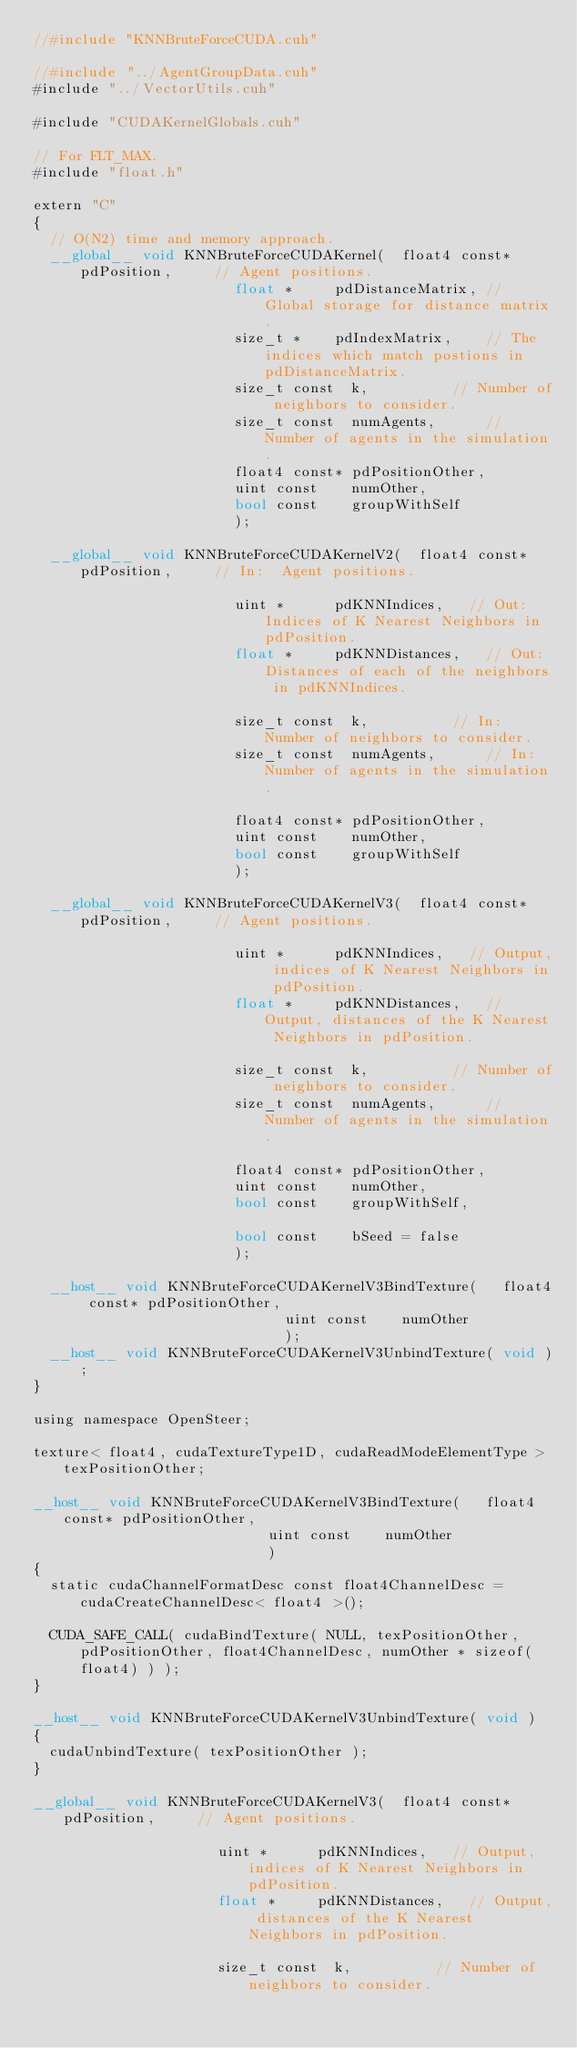<code> <loc_0><loc_0><loc_500><loc_500><_Cuda_>//#include "KNNBruteForceCUDA.cuh"

//#include "../AgentGroupData.cuh"
#include "../VectorUtils.cuh"

#include "CUDAKernelGlobals.cuh"

// For FLT_MAX.
#include "float.h"

extern "C"
{
	// O(N2) time and memory approach.
	__global__ void KNNBruteForceCUDAKernel(	float4 const*	pdPosition,			// Agent positions.
												float *			pdDistanceMatrix,	// Global storage for distance matrix.
												size_t *		pdIndexMatrix,		// The indices which match postions in pdDistanceMatrix.
												size_t const	k,					// Number of neighbors to consider.
												size_t const	numAgents,			// Number of agents in the simulation.
												float4 const*	pdPositionOther,
												uint const		numOther,
												bool const		groupWithSelf
												);

	__global__ void KNNBruteForceCUDAKernelV2(	float4 const*	pdPosition,			// In:	Agent positions.

												uint *			pdKNNIndices,		// Out:	Indices of K Nearest Neighbors in pdPosition.
												float *			pdKNNDistances,		// Out:	Distances of each of the neighbors in pdKNNIndices.

												size_t const	k,					// In:	Number of neighbors to consider.
												size_t const	numAgents,			// In:	Number of agents in the simulation.

												float4 const*	pdPositionOther,
												uint const		numOther,
												bool const		groupWithSelf
												);

	__global__ void KNNBruteForceCUDAKernelV3(	float4 const*	pdPosition,			// Agent positions.

												uint *			pdKNNIndices,		// Output, indices of K Nearest Neighbors in pdPosition.
												float *			pdKNNDistances,		// Output, distances of the K Nearest Neighbors in pdPosition.

												size_t const	k,					// Number of neighbors to consider.
												size_t const	numAgents,			// Number of agents in the simulation.

												float4 const*	pdPositionOther,
												uint const		numOther,
												bool const		groupWithSelf,

												bool const		bSeed = false
												);

	__host__ void KNNBruteForceCUDAKernelV3BindTexture(		float4 const*	pdPositionOther,
															uint const		numOther
															);
	__host__ void KNNBruteForceCUDAKernelV3UnbindTexture( void );
}

using namespace OpenSteer;

texture< float4, cudaTextureType1D, cudaReadModeElementType >	texPositionOther;

__host__ void KNNBruteForceCUDAKernelV3BindTexture(		float4 const*	pdPositionOther,
														uint const		numOther
														)
{
	static cudaChannelFormatDesc const float4ChannelDesc = cudaCreateChannelDesc< float4 >();

	CUDA_SAFE_CALL( cudaBindTexture( NULL, texPositionOther, pdPositionOther, float4ChannelDesc, numOther * sizeof(float4) ) );
}

__host__ void KNNBruteForceCUDAKernelV3UnbindTexture( void )
{
	cudaUnbindTexture( texPositionOther );
}

__global__ void KNNBruteForceCUDAKernelV3(	float4 const*	pdPosition,			// Agent positions.

											uint *			pdKNNIndices,		// Output, indices of K Nearest Neighbors in pdPosition.
											float *			pdKNNDistances,		// Output, distances of the K Nearest Neighbors in pdPosition.

											size_t const	k,					// Number of neighbors to consider.</code> 